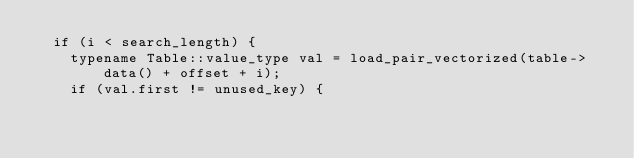<code> <loc_0><loc_0><loc_500><loc_500><_Cuda_>  if (i < search_length) {
    typename Table::value_type val = load_pair_vectorized(table->data() + offset + i);
    if (val.first != unused_key) {</code> 